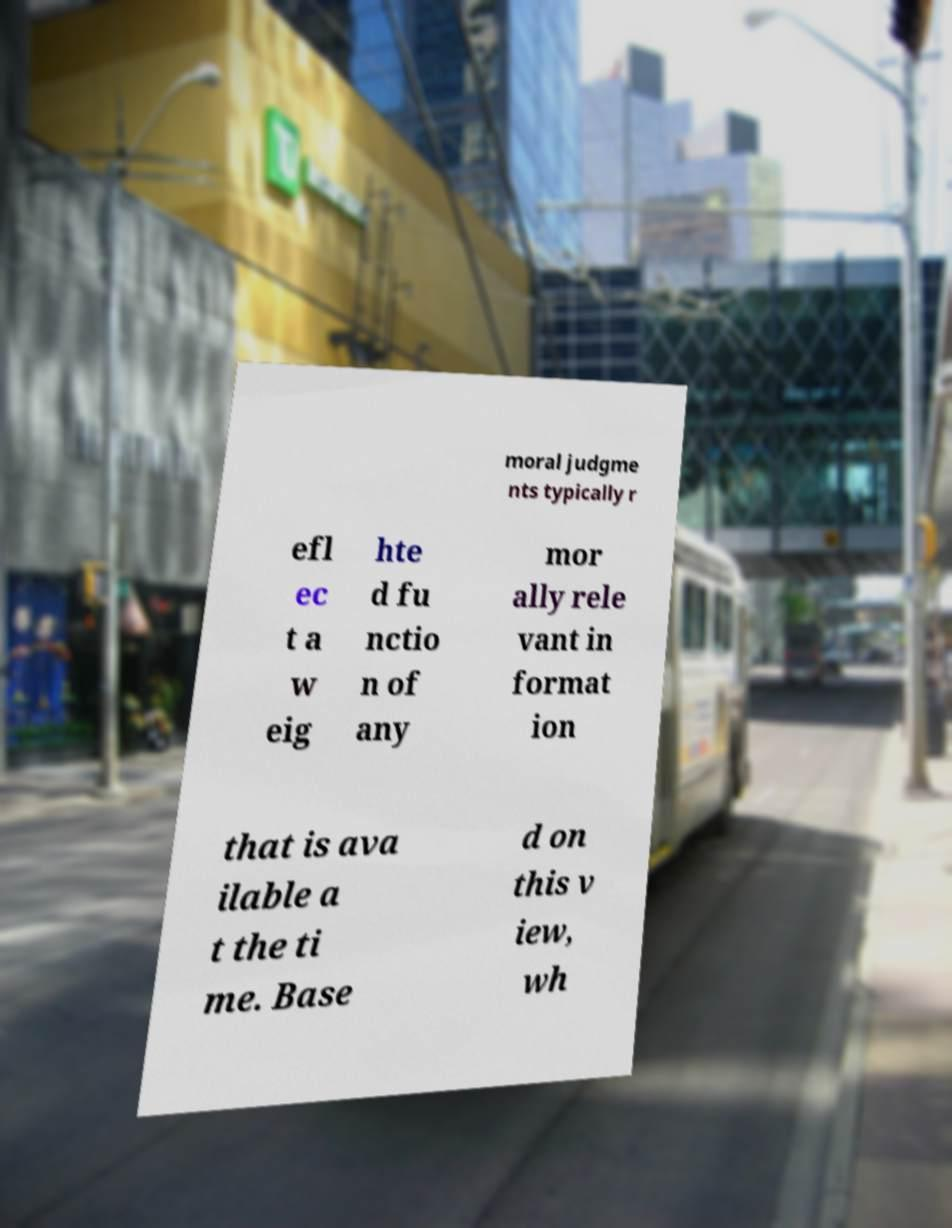Could you extract and type out the text from this image? moral judgme nts typically r efl ec t a w eig hte d fu nctio n of any mor ally rele vant in format ion that is ava ilable a t the ti me. Base d on this v iew, wh 